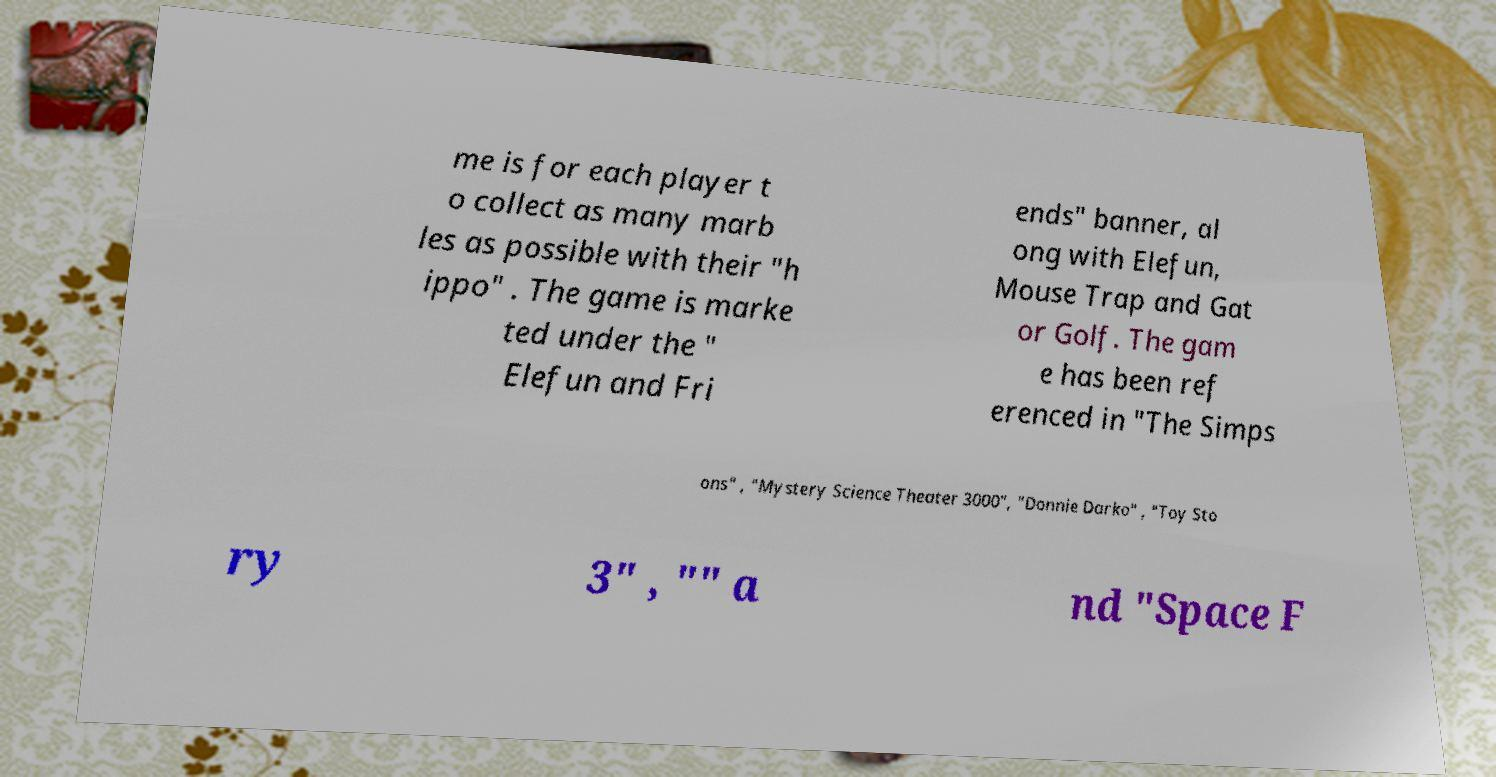Can you accurately transcribe the text from the provided image for me? me is for each player t o collect as many marb les as possible with their "h ippo" . The game is marke ted under the " Elefun and Fri ends" banner, al ong with Elefun, Mouse Trap and Gat or Golf. The gam e has been ref erenced in "The Simps ons" , "Mystery Science Theater 3000", "Donnie Darko" , "Toy Sto ry 3" , "" a nd "Space F 